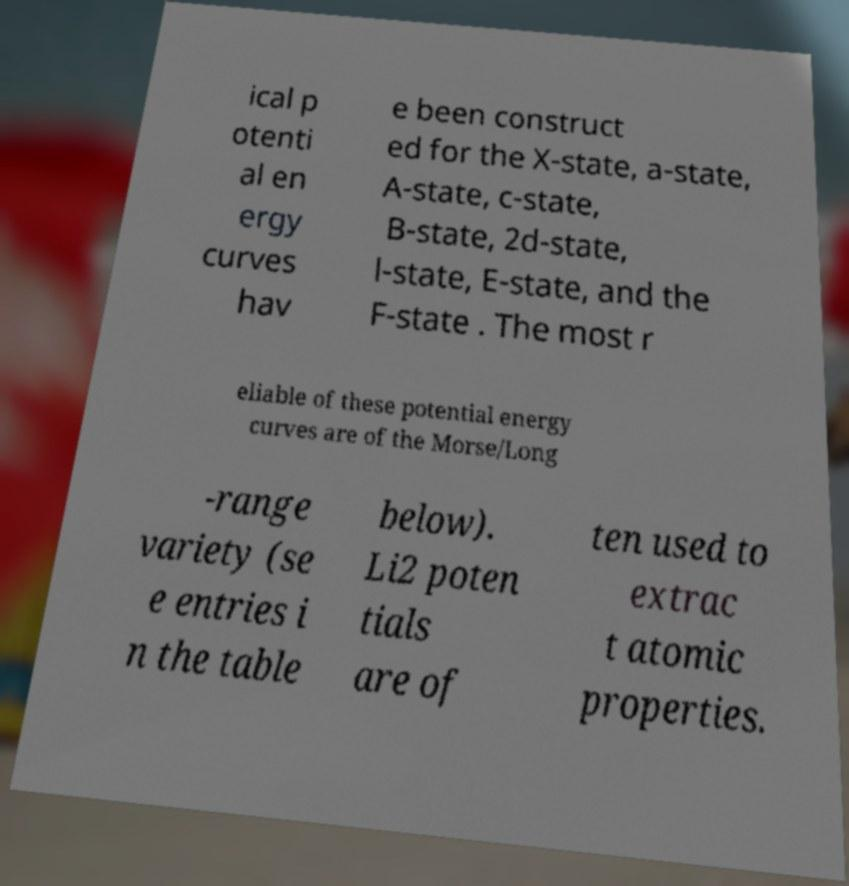Please read and relay the text visible in this image. What does it say? ical p otenti al en ergy curves hav e been construct ed for the X-state, a-state, A-state, c-state, B-state, 2d-state, l-state, E-state, and the F-state . The most r eliable of these potential energy curves are of the Morse/Long -range variety (se e entries i n the table below). Li2 poten tials are of ten used to extrac t atomic properties. 